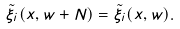<formula> <loc_0><loc_0><loc_500><loc_500>\tilde { \xi } _ { i } ( x , w + N ) = \tilde { \xi } _ { i } ( x , w ) .</formula> 